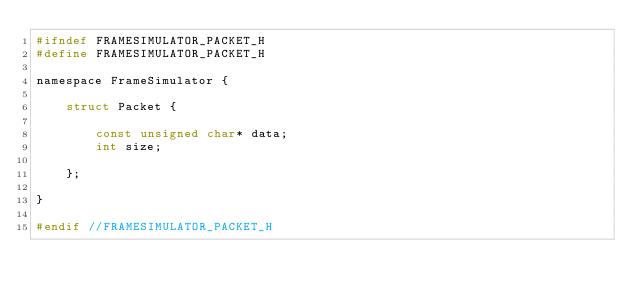Convert code to text. <code><loc_0><loc_0><loc_500><loc_500><_C_>#ifndef FRAMESIMULATOR_PACKET_H
#define FRAMESIMULATOR_PACKET_H

namespace FrameSimulator {

    struct Packet {

        const unsigned char* data;
        int size;

    };

}

#endif //FRAMESIMULATOR_PACKET_H
</code> 